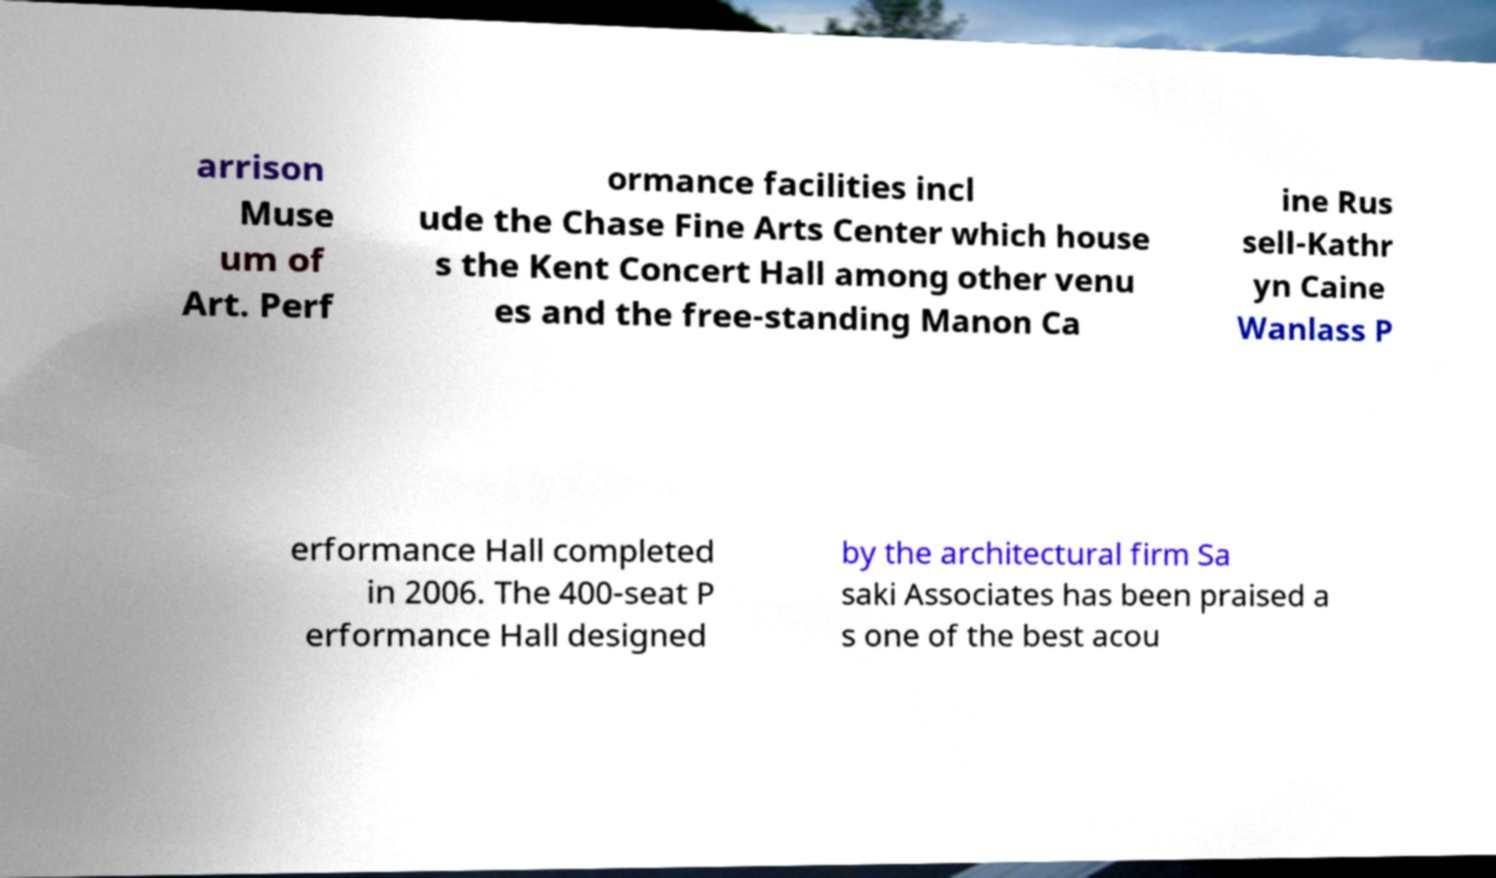There's text embedded in this image that I need extracted. Can you transcribe it verbatim? arrison Muse um of Art. Perf ormance facilities incl ude the Chase Fine Arts Center which house s the Kent Concert Hall among other venu es and the free-standing Manon Ca ine Rus sell-Kathr yn Caine Wanlass P erformance Hall completed in 2006. The 400-seat P erformance Hall designed by the architectural firm Sa saki Associates has been praised a s one of the best acou 